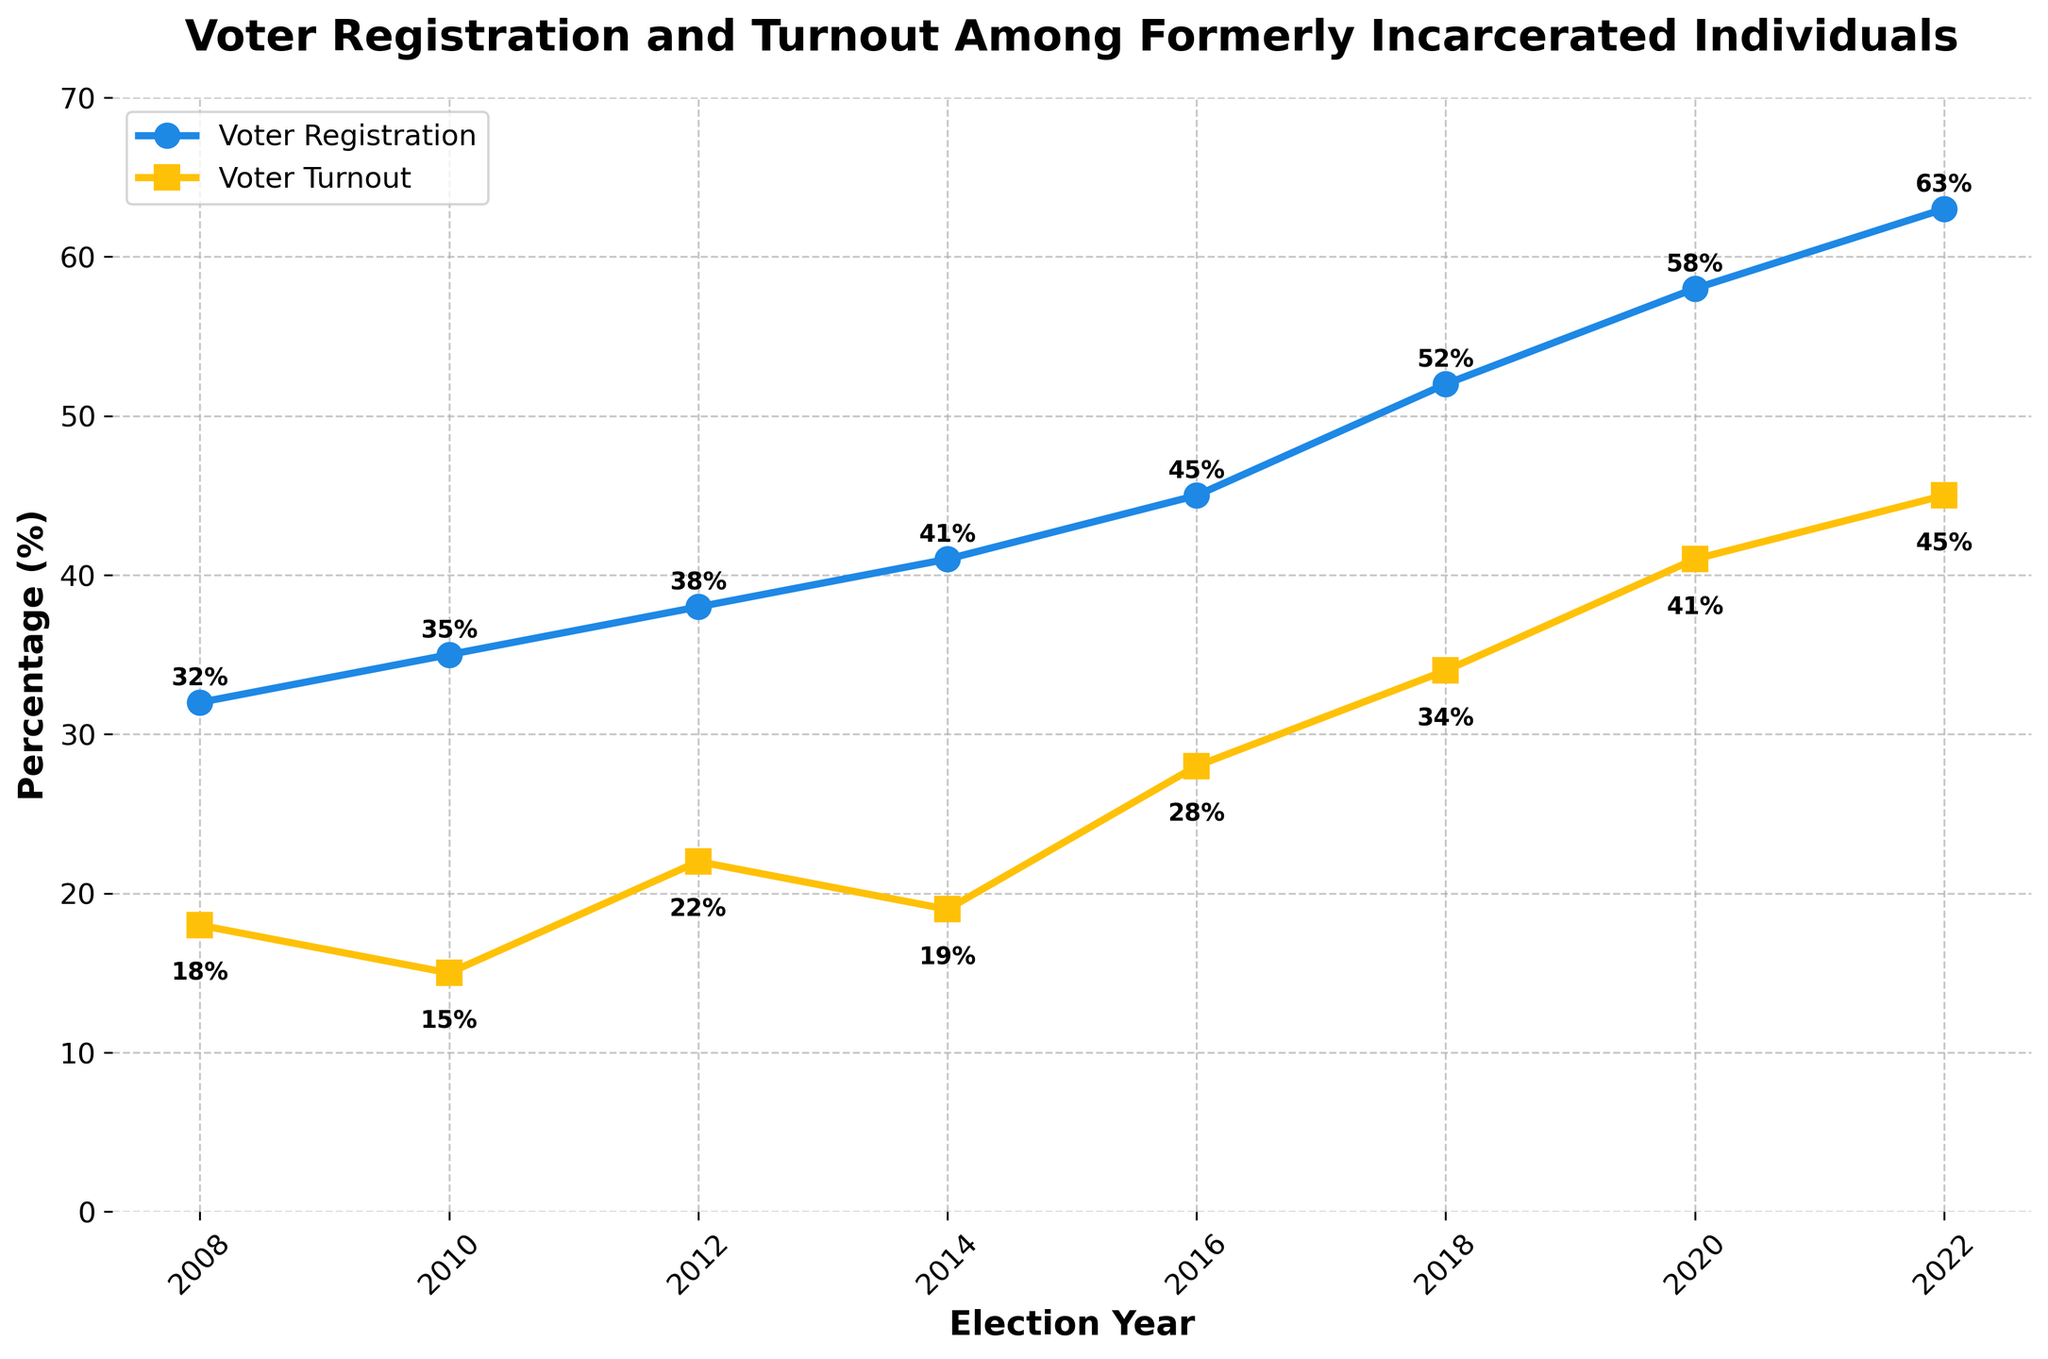What is the percentage increase in voter registration among formerly incarcerated individuals from 2008 to 2022? To find the percentage increase, subtract the voter registration rate in 2008 from the rate in 2022, then divide by the rate in 2008 and multiply by 100. So, (63 - 32) / 32 * 100 = 96.875%.
Answer: 96.875% Which election year saw the highest voter turnout among formerly incarcerated individuals? By looking at the line chart, the highest voter turnout among formerly incarcerated individuals can be visually identified at the peak of the line representing voter turnout. This peak is at the 2022 mark.
Answer: 2022 How does the voter turnout percentage in 2020 compare to the voter turnout percentage in 2016? According to the chart, the voter turnout in 2020 is 41%, and in 2016 it is 28%. To compare, subtract the 2016 turnout from the 2020 turnout: 41% - 28% = 13%. This shows an increase of 13 percentage points.
Answer: 13% increase By how much did the formerly incarcerated voter registration rate increase between each election cycle on average? Calculate the differences in voter registration rates between consecutive election cycles: (35-32), (38-35), (41-38), (45-41), (52-45), (58-52), and (63-58). Then average these differences. The individual increases are 3, 3, 3, 4, 7, 6, and 5. The average is (3 + 3 + 3 + 4 + 7 + 6 + 5) / 7 = 4.43%.
Answer: 4.43% Between which consecutive election years did the formerly incarcerated voter turnout experience the greatest increase? By checking the chart, compute the differences between voter turnout percentages for consecutive election years. They are: (15-18), (22-15), (19-22), (28-19), (34-28), (41-34), and (45-41). This results in -3, 7, -3, 9, 6, 7, and 4. The greatest increase is 9 between the years 2014 and 2016.
Answer: 2014 and 2016 What is the difference in voter registration percentage between the highest and the lowest election year? Identify the highest and lowest voter registration percentages from the chart, which are 63% in 2022 and 32% in 2008, respectively. The difference is 63 - 32 = 31%.
Answer: 31% What trend do you observe in voter turnout from 2008 to 2022? Analyzing the line representing voter turnout, the trend shows a generally increasing pattern with minor fluctuations. This overall upward trend indicates a consistent increase in voter turnout among formerly incarcerated individuals over the years.
Answer: Increasing trend What were the voter turnout percentages during the midterm elections in the observed period? Refer to the years 2010, 2014, 2018, and 2022 which are midterm election years. The corresponding turnout percentages are 15%, 19%, 34%, and 45%, respectively.
Answer: 15%, 19%, 34%, 45% What is the difference in voter registration percentage between the midterm year 2010 and the presidential election year 2012? The voter registration percentage in 2010 is 35% and in 2012 it is 38%. To find the difference, subtract 35 from 38: 38 - 35 = 3%.
Answer: 3% By how many percentage points did both voter registration and turnout increase from 2018 to 2020? For registration, the increase from 2018 (52%) to 2020 (58%) is 58 - 52 = 6%. For turnout, the increase from 2018 (34%) to 2020 (41%) is 41 - 34 = 7%. Therefore, the increases are 6 percentage points for registration and 7 percentage points for turnout.
Answer: 6%, 7% 